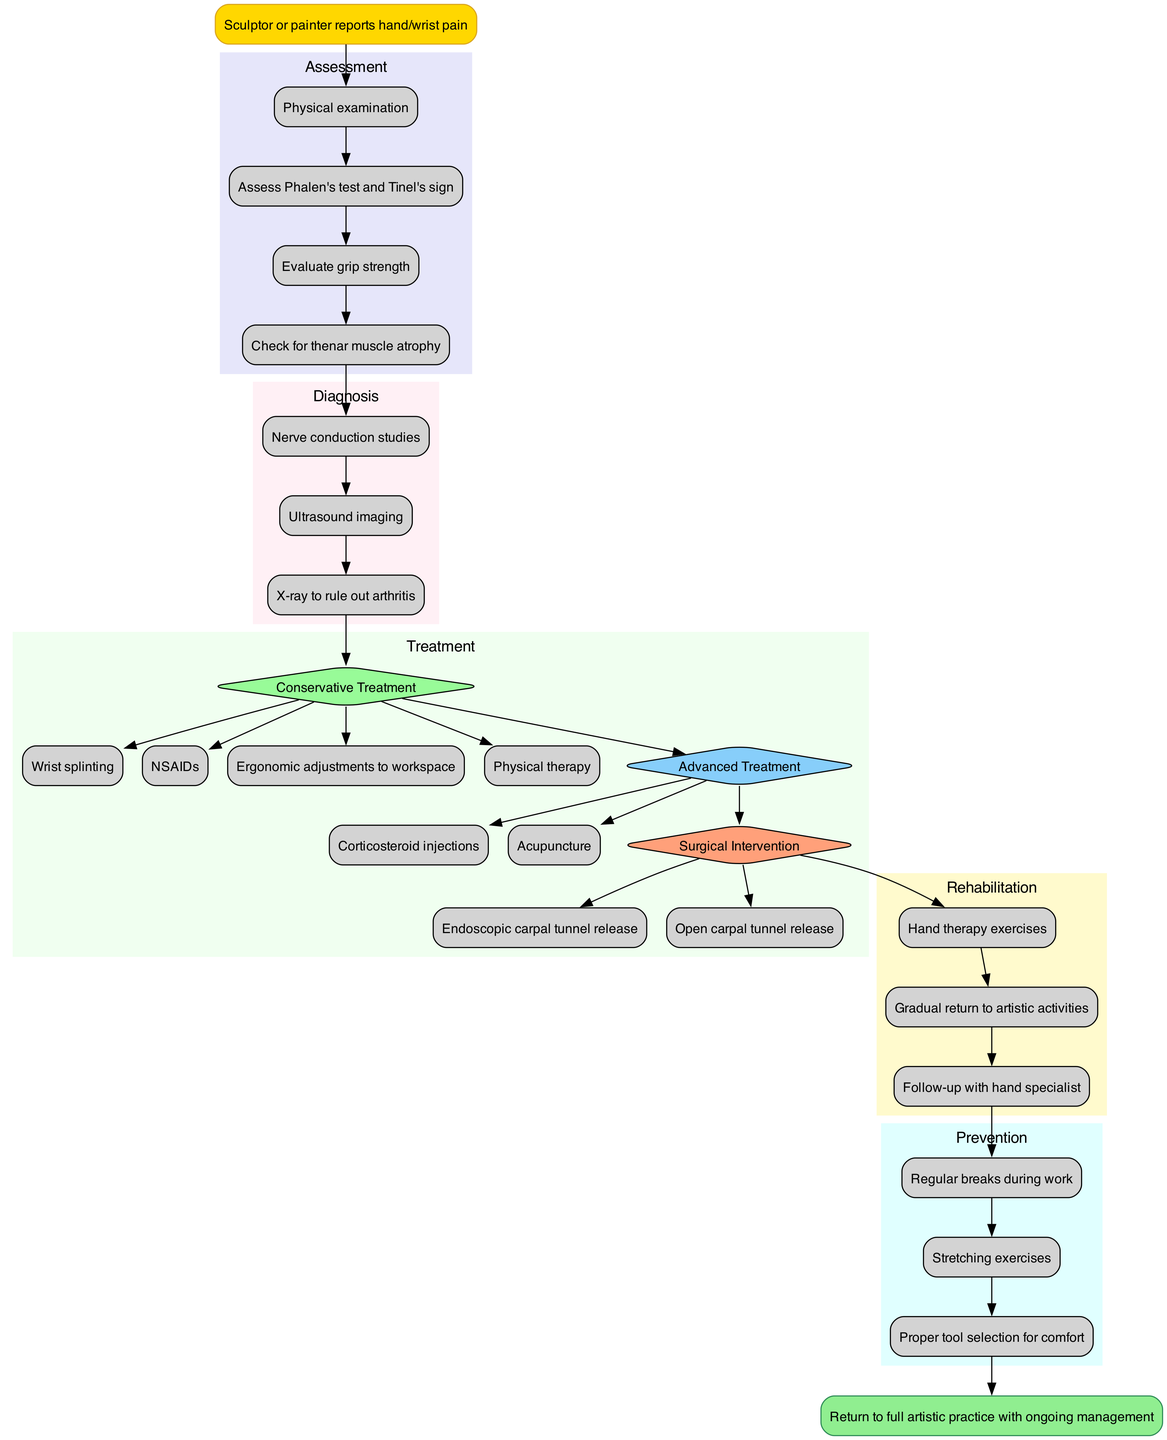What is the starting point of the clinical pathway? The starting point, indicated in the diagram, is the node "Sculptor or painter reports hand/wrist pain."
Answer: Sculptor or painter reports hand/wrist pain How many assessment steps are included in the pathway? The diagram lists four assessment steps which are represented in the assessment cluster.
Answer: 4 What node follows the assessment phase? After completing the assessment phase, the next step is indicated as "Nerve conduction studies," which is the first in the diagnosis cluster.
Answer: Nerve conduction studies What types of treatment are presented after the diagnosis? The diagram categorizes treatments into conservative, advanced, and surgical treatment. The first treatment listed in the conservative section is "Wrist splinting."
Answer: Conservative Treatment, Advanced Treatment, Surgical Intervention Which therapy is listed under rehabilitation? The diagram includes "Hand therapy exercises" as the first listed rehabilitation step.
Answer: Hand therapy exercises After conservative treatment, what comes next in the diagram? Following the conservative treatment, the diagram leads to an advanced treatment option, highlighted as "Advanced Treatment."
Answer: Advanced Treatment What is the final step of the clinical pathway? The endpoint of the clinical pathway is specified as "Return to full artistic practice with ongoing management."
Answer: Return to full artistic practice with ongoing management What should be done to prevent carpal tunnel syndrome during artistic activities? The prevention section identifies "Regular breaks during work" as the first preventive measure listed in the diagram.
Answer: Regular breaks during work How are the advanced treatment options connected to conservative treatment? In the diagram, the advanced treatment options are branched off from the conservative treatment node, indicating that they come after the conservative options are explored.
Answer: They branch off from conservative treatment 